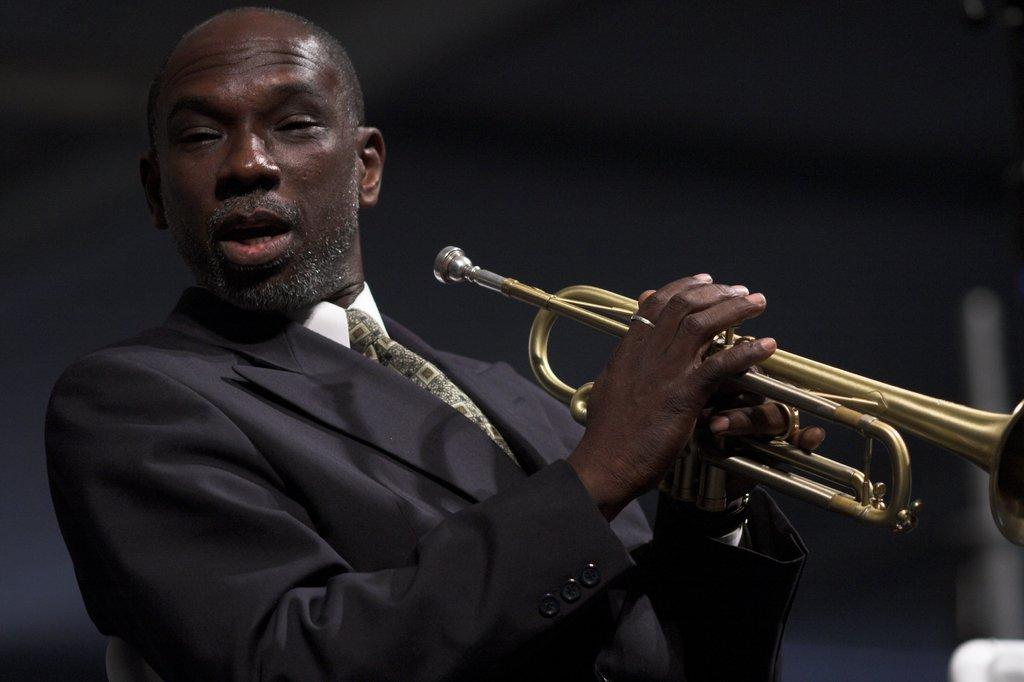What is the main subject of the image? There is a person in the image. What is the person holding in the image? The person is holding a trumpet. What disease is the person suffering from in the image? There is no indication of any disease in the image; it only shows a person holding a trumpet. 